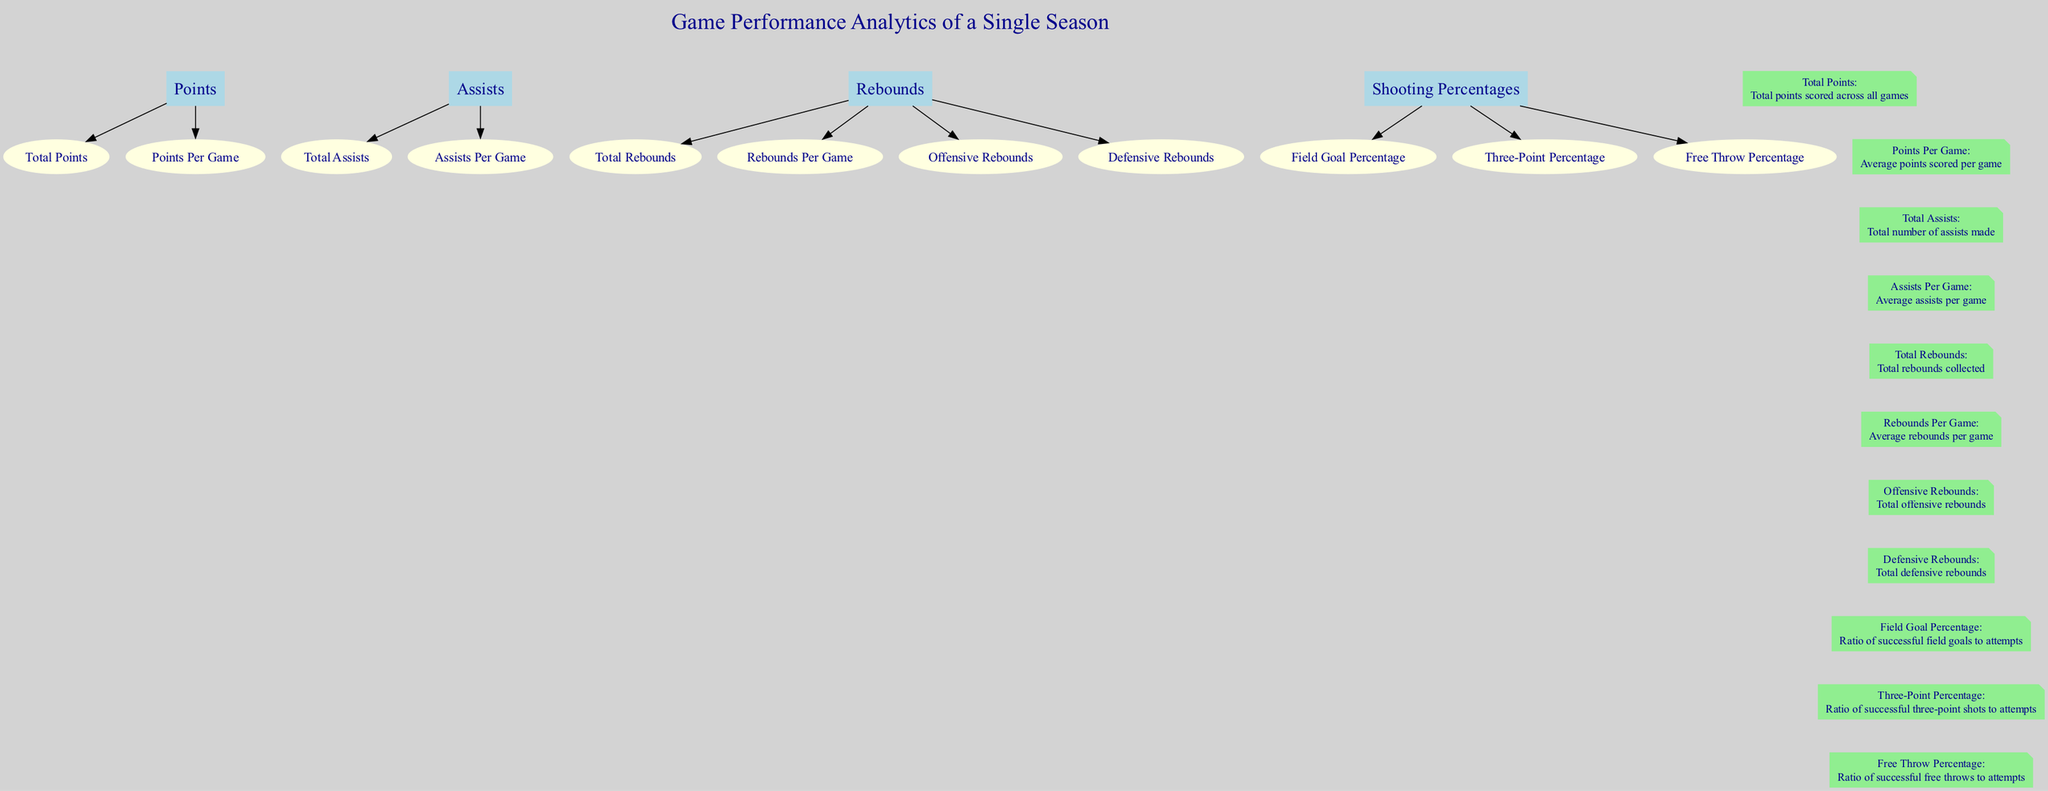What are the subcategories under Rebounds? The diagram shows the category 'Rebounds' has four subcategories listed: 'Total Rebounds', 'Rebounds Per Game', 'Offensive Rebounds', and 'Defensive Rebounds'. I can find these subcategories connected to the 'Rebounds' node and read their names directly.
Answer: Total Rebounds, Rebounds Per Game, Offensive Rebounds, Defensive Rebounds What is the color of the legend nodes? The diagram uses light green for all the legend nodes. By examining the color attribute of the nodes labeled as legend in the diagram, I can confirm their appearance.
Answer: Light green How many subcategories are there in total? The categories consist of Points (2), Assists (2), Rebounds (4), and Shooting Percentages (3). Adding them together gives a total of 2 + 2 + 4 + 3 = 11 subcategories.
Answer: 11 What is the definition of Field Goal Percentage? The legend node connected to the 'Field Goal Percentage' subcategory describes it as the ratio of successful field goals to attempts. I reference the specific node in the legend to extract the definition.
Answer: Ratio of successful field goals to attempts Which category has the highest number of subcategories? By counting the subcategories listed under each category, 'Rebounds' has four subcategories, while the others have fewer (2 for Points and Assists, and 3 for Shooting Percentages). Hence, 'Rebounds' has the highest number.
Answer: Rebounds What two subcategories under Points are present in the diagram? The diagram outlines two subcategories under 'Points': 'Total Points' and 'Points Per Game'. I can visually identify and list these subcategories connected to the main 'Points' node.
Answer: Total Points, Points Per Game Which category is depicted as a note in the diagram? The diagram specifies that the legend is represented as a note type node, which includes all the definitions for each key term. I determine the nature of the nodes by their shape description in the diagram.
Answer: The legend What is the relationship between Points and Assists in the diagram? The diagram does not explicitly define a direct relationship between Points and Assists as they are separate categories. However, they are both important metrics within the larger framework of game performance, connected to the title node. This indicates they are part of the analytics being represented but without a direct link.
Answer: No direct relationship 